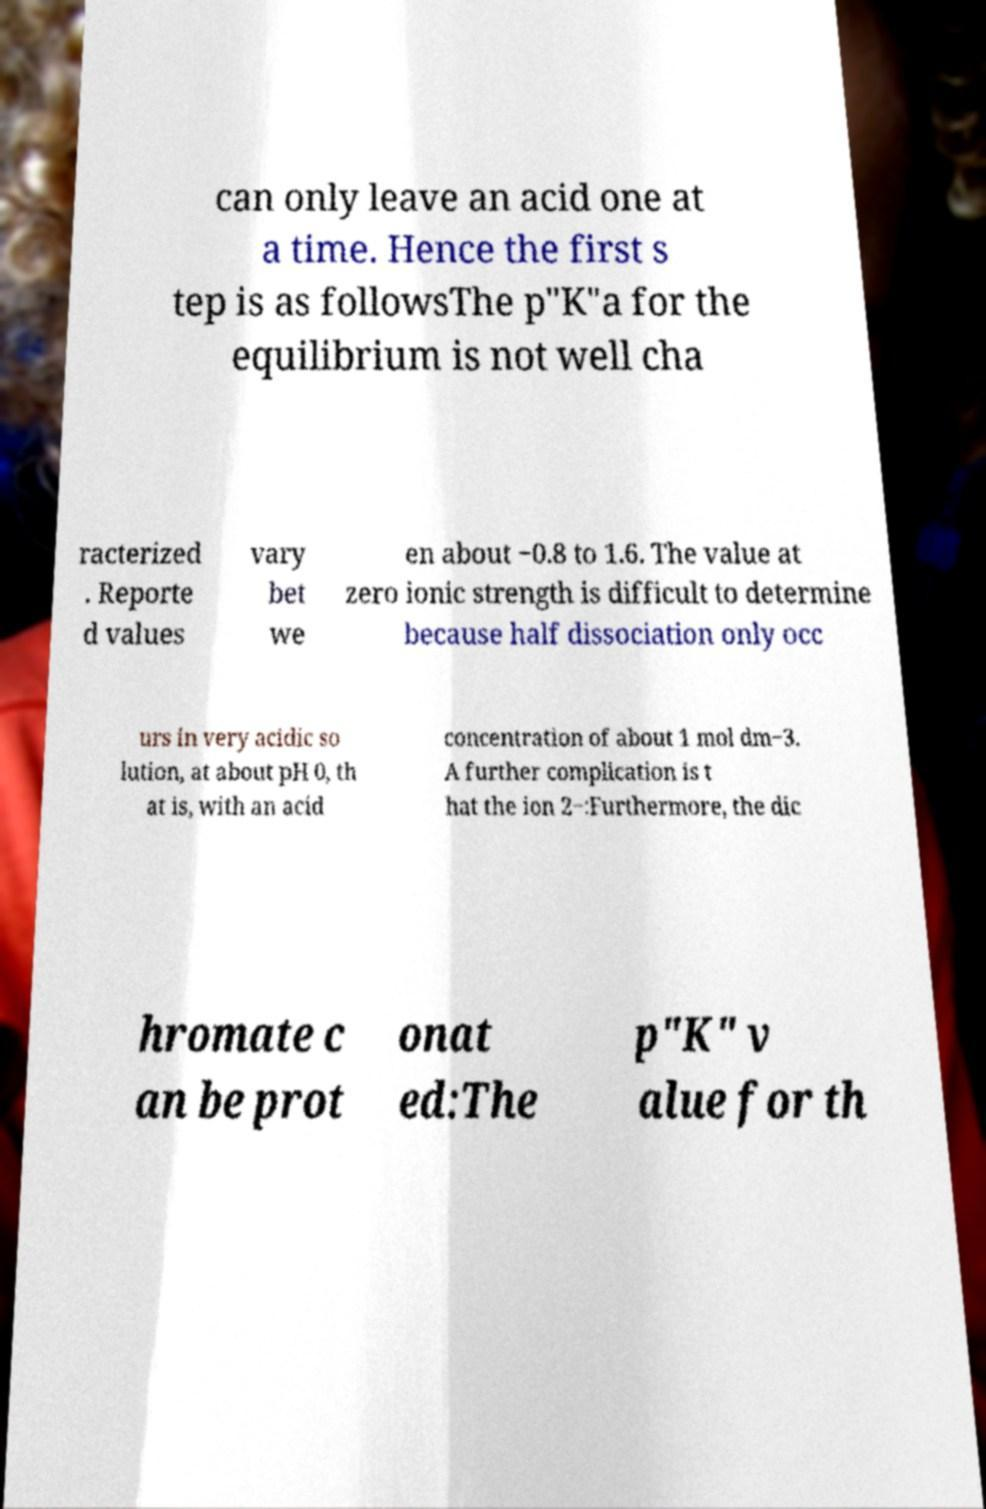Can you read and provide the text displayed in the image?This photo seems to have some interesting text. Can you extract and type it out for me? can only leave an acid one at a time. Hence the first s tep is as followsThe p"K"a for the equilibrium is not well cha racterized . Reporte d values vary bet we en about −0.8 to 1.6. The value at zero ionic strength is difficult to determine because half dissociation only occ urs in very acidic so lution, at about pH 0, th at is, with an acid concentration of about 1 mol dm−3. A further complication is t hat the ion 2−:Furthermore, the dic hromate c an be prot onat ed:The p"K" v alue for th 